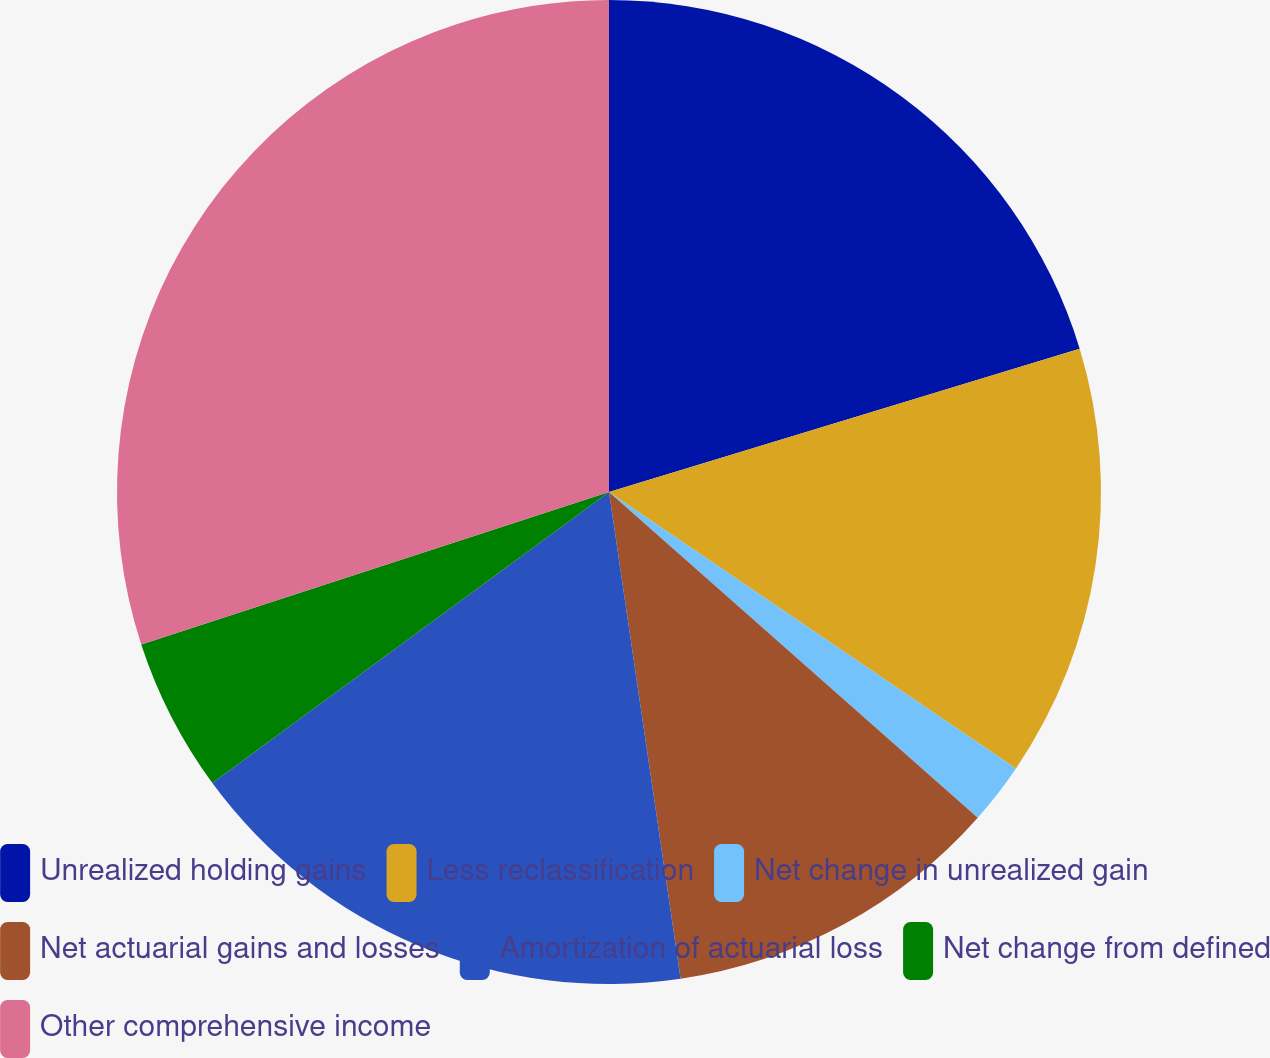Convert chart. <chart><loc_0><loc_0><loc_500><loc_500><pie_chart><fcel>Unrealized holding gains<fcel>Less reclassification<fcel>Net change in unrealized gain<fcel>Net actuarial gains and losses<fcel>Amortization of actuarial loss<fcel>Net change from defined<fcel>Other comprehensive income<nl><fcel>20.3%<fcel>14.2%<fcel>2.02%<fcel>11.16%<fcel>17.25%<fcel>5.06%<fcel>30.02%<nl></chart> 